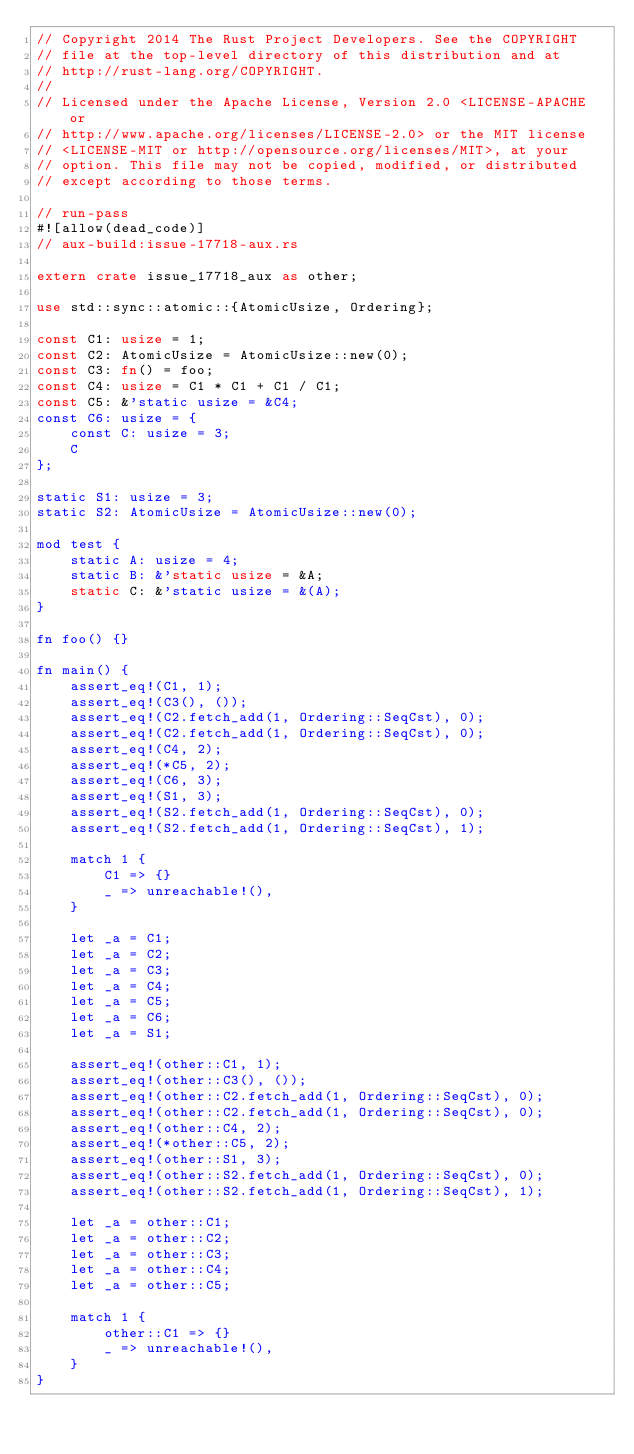<code> <loc_0><loc_0><loc_500><loc_500><_Rust_>// Copyright 2014 The Rust Project Developers. See the COPYRIGHT
// file at the top-level directory of this distribution and at
// http://rust-lang.org/COPYRIGHT.
//
// Licensed under the Apache License, Version 2.0 <LICENSE-APACHE or
// http://www.apache.org/licenses/LICENSE-2.0> or the MIT license
// <LICENSE-MIT or http://opensource.org/licenses/MIT>, at your
// option. This file may not be copied, modified, or distributed
// except according to those terms.

// run-pass
#![allow(dead_code)]
// aux-build:issue-17718-aux.rs

extern crate issue_17718_aux as other;

use std::sync::atomic::{AtomicUsize, Ordering};

const C1: usize = 1;
const C2: AtomicUsize = AtomicUsize::new(0);
const C3: fn() = foo;
const C4: usize = C1 * C1 + C1 / C1;
const C5: &'static usize = &C4;
const C6: usize = {
    const C: usize = 3;
    C
};

static S1: usize = 3;
static S2: AtomicUsize = AtomicUsize::new(0);

mod test {
    static A: usize = 4;
    static B: &'static usize = &A;
    static C: &'static usize = &(A);
}

fn foo() {}

fn main() {
    assert_eq!(C1, 1);
    assert_eq!(C3(), ());
    assert_eq!(C2.fetch_add(1, Ordering::SeqCst), 0);
    assert_eq!(C2.fetch_add(1, Ordering::SeqCst), 0);
    assert_eq!(C4, 2);
    assert_eq!(*C5, 2);
    assert_eq!(C6, 3);
    assert_eq!(S1, 3);
    assert_eq!(S2.fetch_add(1, Ordering::SeqCst), 0);
    assert_eq!(S2.fetch_add(1, Ordering::SeqCst), 1);

    match 1 {
        C1 => {}
        _ => unreachable!(),
    }

    let _a = C1;
    let _a = C2;
    let _a = C3;
    let _a = C4;
    let _a = C5;
    let _a = C6;
    let _a = S1;

    assert_eq!(other::C1, 1);
    assert_eq!(other::C3(), ());
    assert_eq!(other::C2.fetch_add(1, Ordering::SeqCst), 0);
    assert_eq!(other::C2.fetch_add(1, Ordering::SeqCst), 0);
    assert_eq!(other::C4, 2);
    assert_eq!(*other::C5, 2);
    assert_eq!(other::S1, 3);
    assert_eq!(other::S2.fetch_add(1, Ordering::SeqCst), 0);
    assert_eq!(other::S2.fetch_add(1, Ordering::SeqCst), 1);

    let _a = other::C1;
    let _a = other::C2;
    let _a = other::C3;
    let _a = other::C4;
    let _a = other::C5;

    match 1 {
        other::C1 => {}
        _ => unreachable!(),
    }
}
</code> 